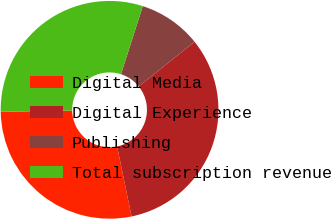<chart> <loc_0><loc_0><loc_500><loc_500><pie_chart><fcel>Digital Media<fcel>Digital Experience<fcel>Publishing<fcel>Total subscription revenue<nl><fcel>27.94%<fcel>32.51%<fcel>9.31%<fcel>30.23%<nl></chart> 